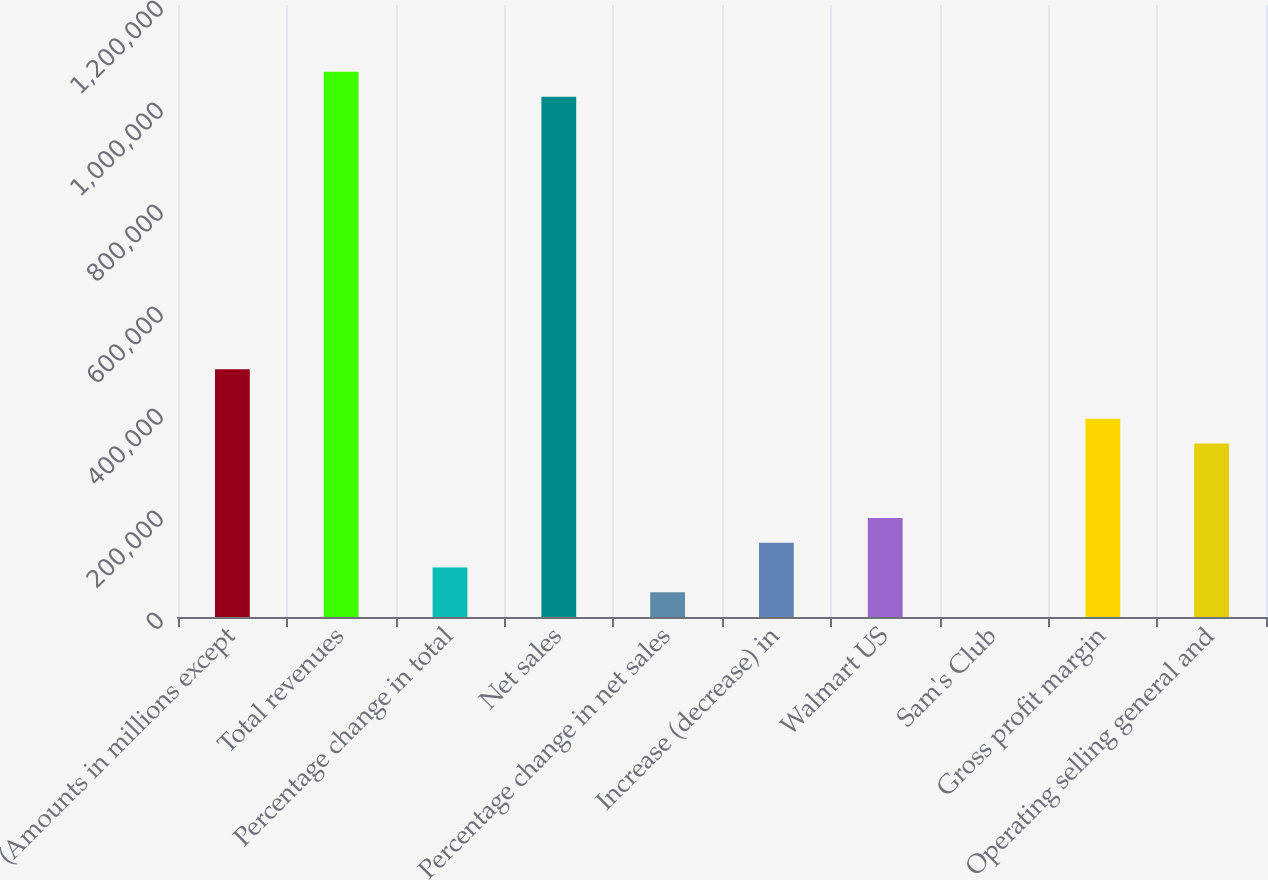Convert chart to OTSL. <chart><loc_0><loc_0><loc_500><loc_500><bar_chart><fcel>(Amounts in millions except<fcel>Total revenues<fcel>Percentage change in total<fcel>Net sales<fcel>Percentage change in net sales<fcel>Increase (decrease) in<fcel>Walmart US<fcel>Sam's Club<fcel>Gross profit margin<fcel>Operating selling general and<nl><fcel>485873<fcel>1.06892e+06<fcel>97175<fcel>1.02033e+06<fcel>48587.8<fcel>145762<fcel>194350<fcel>0.5<fcel>388698<fcel>340111<nl></chart> 